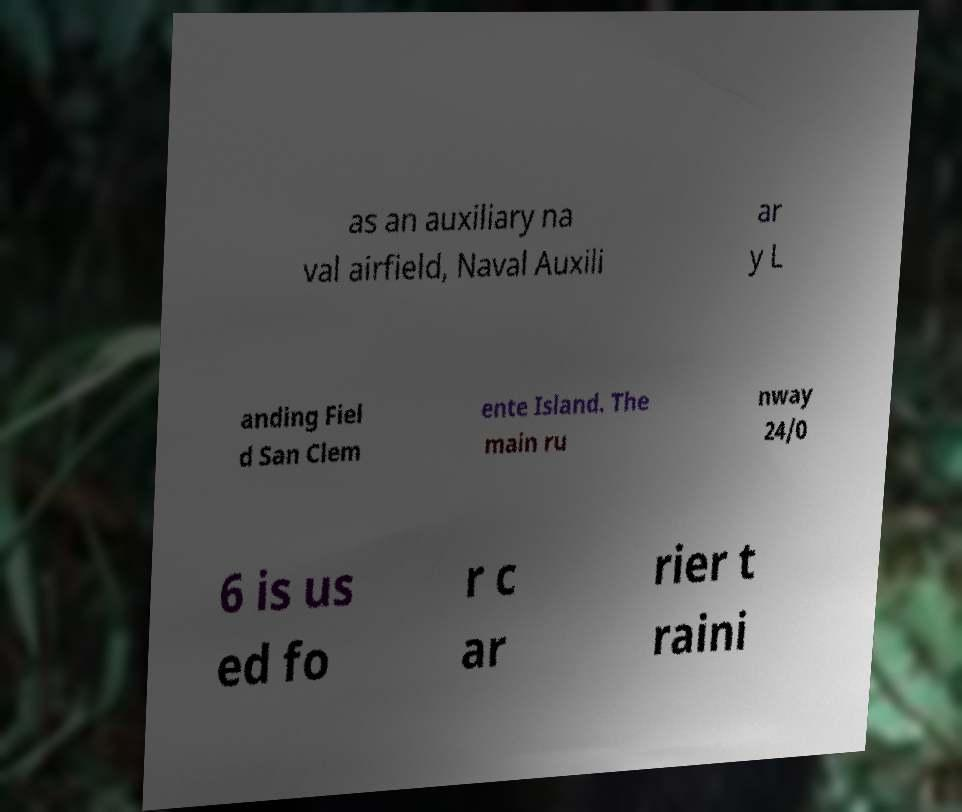For documentation purposes, I need the text within this image transcribed. Could you provide that? as an auxiliary na val airfield, Naval Auxili ar y L anding Fiel d San Clem ente Island. The main ru nway 24/0 6 is us ed fo r c ar rier t raini 